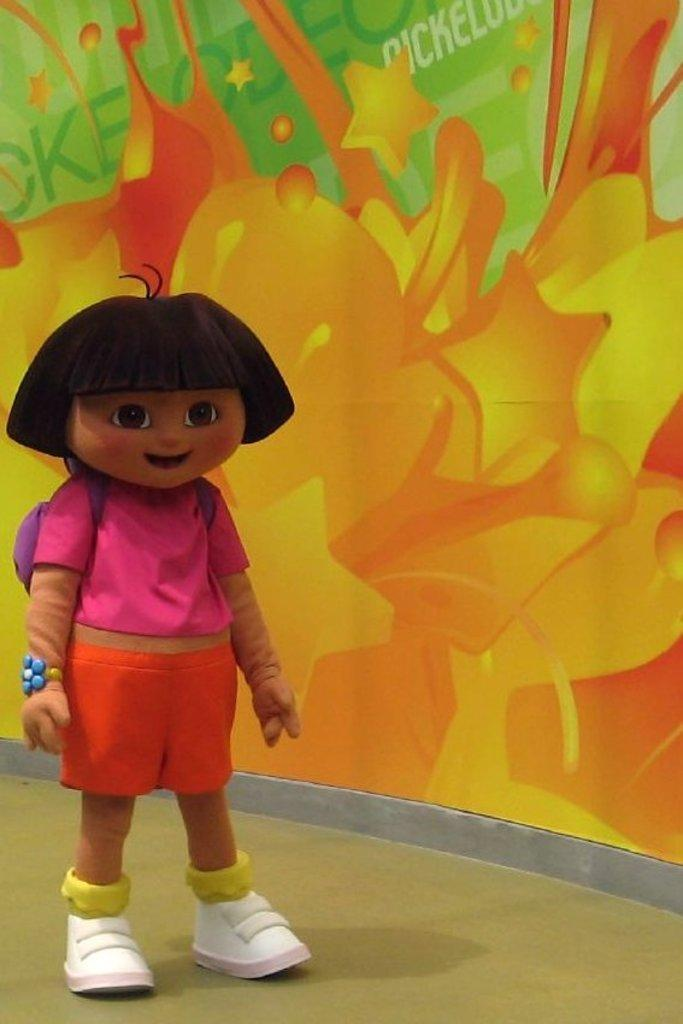What is the main subject in the image? There is a mascot in the image. Where is the mascot located? The mascot is standing on the floor. What can be seen in the background of the image? There is a sticker on the wall in the background of the image. What type of toys can be seen in the hands of the mascot in the image? There are no toys visible in the hands of the mascot in the image. 